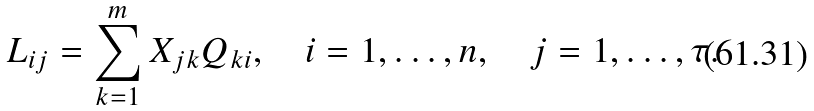Convert formula to latex. <formula><loc_0><loc_0><loc_500><loc_500>L _ { i j } = \sum _ { k = 1 } ^ { m } X _ { j k } Q _ { k i } , \quad i = 1 , \dots , n , \quad j = 1 , \dots , \tau .</formula> 